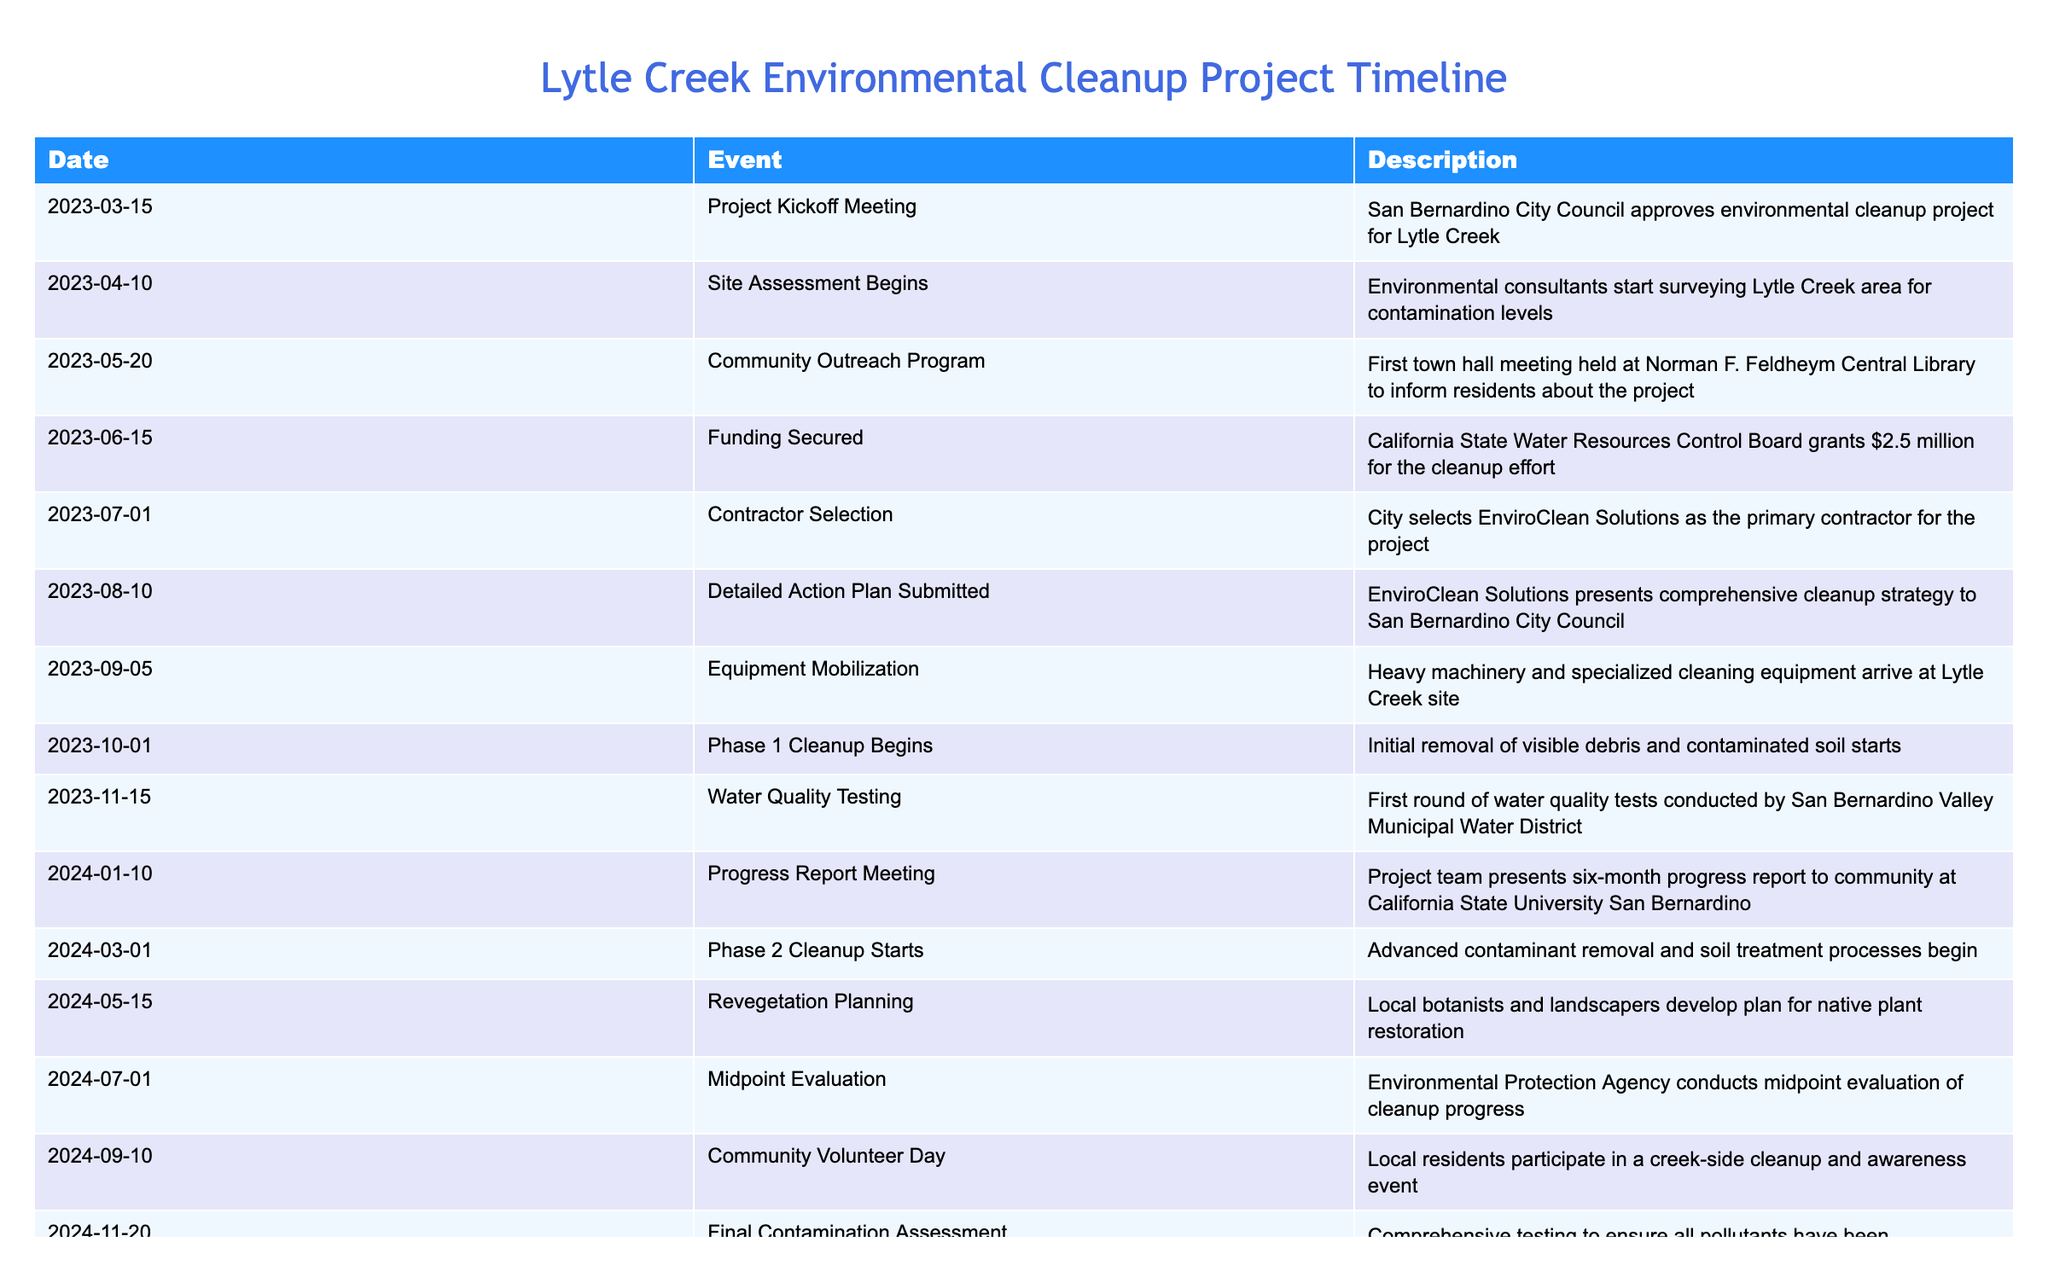What date did the project kickoff meeting occur? The table lists the event name "Project Kickoff Meeting" under the "Event" column, and the corresponding date is found in the "Date" column for that event. I can see that the date is "2023-03-15".
Answer: 2023-03-15 How many months passed between the kickoff meeting and the funding being secured? From the "Date" column, the kickoff meeting happened on "2023-03-15" and the funding was secured on "2023-06-15". Counting the months from March to June, we have March, April, May, and June, which totals 3 months.
Answer: 3 Was the community outreach program held before or after the site assessment began? The community outreach program took place on "2023-05-20" and the site assessment began on "2023-04-10". Comparing the two dates, May comes after April. Therefore, the outreach program was held after the site assessment began.
Answer: After What event occurred immediately before the "Phase 1 Cleanup Begins"? The table shows that "Equipment Mobilization" took place on "2023-09-05", and "Phase 1 Cleanup Begins" happened on "2023-10-01". Since there are no other events listed in between, we can infer that "Equipment Mobilization" was the event immediately before the cleaning phase began.
Answer: Equipment Mobilization What is the total number of events listed in the timeline? By counting the number of distinct events in the "Event" column, we can see there are 15 entries. Hence, the total number of events listed is 15.
Answer: 15 If the "Final Contamination Assessment" is on November 20, 2024, how many months will pass before the "Project Completion Ceremony"? The "Project Completion Ceremony" is scheduled for "2025-03-30". From November 2024 to March 2025, we can count the months: December, January, February, and March, totaling 4 months.
Answer: 4 Did the community participate in a cleanup before or after the midpoint evaluation? The "Midpoint Evaluation" is shown to occur on "2024-07-01", while the "Community Volunteer Day" is on "2024-09-10". Since the community day is listed after the evaluation date, it indicates the community participated after the midpoint evaluation.
Answer: After What percentage of the main cleanup phases are indicated in the timeline? The timeline has 3 main phases listed: Phase 1 Cleanup, Phase 2 Cleanup, and Revegetation. There are 15 events total. Taking the number of cleanup phases (3) and dividing it by the total events (15) gives 20%. We can say that 20% of the events indicate main cleanup phases.
Answer: 20% 